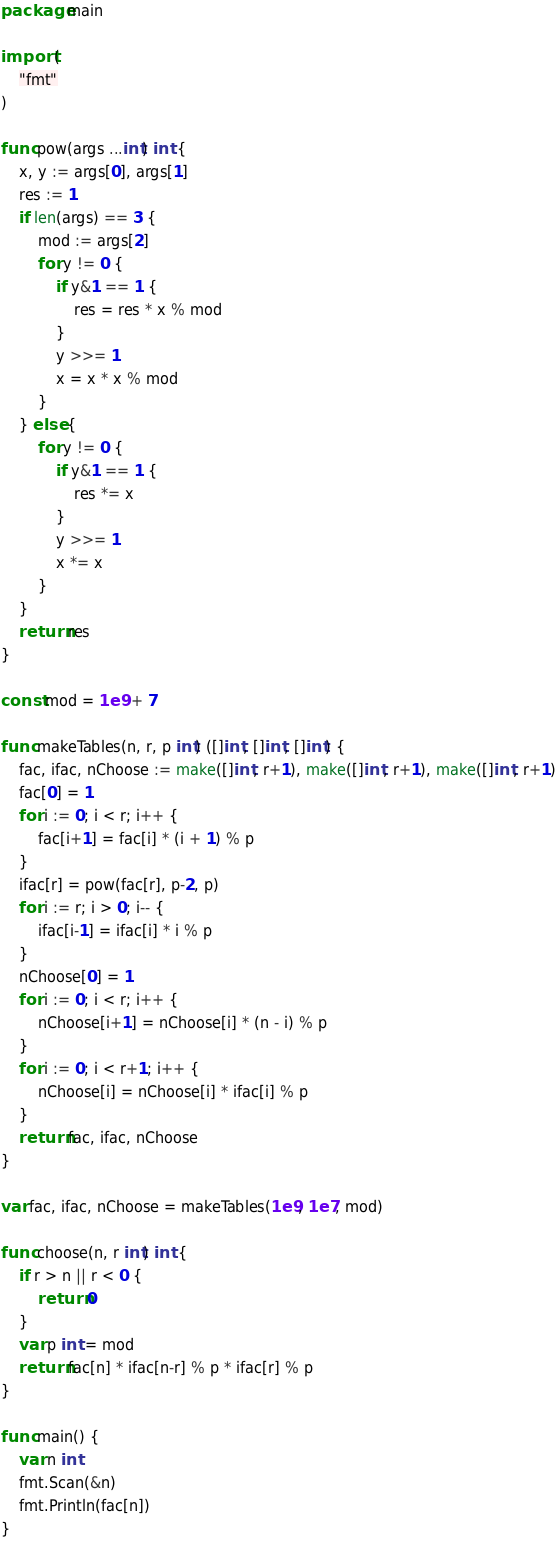<code> <loc_0><loc_0><loc_500><loc_500><_Go_>package main

import (
	"fmt"
)

func pow(args ...int) int {
	x, y := args[0], args[1]
	res := 1
	if len(args) == 3 {
		mod := args[2]
		for y != 0 {
			if y&1 == 1 {
				res = res * x % mod
			}
			y >>= 1
			x = x * x % mod
		}
	} else {
		for y != 0 {
			if y&1 == 1 {
				res *= x
			}
			y >>= 1
			x *= x
		}
	}
	return res
}

const mod = 1e9 + 7

func makeTables(n, r, p int) ([]int, []int, []int) {
	fac, ifac, nChoose := make([]int, r+1), make([]int, r+1), make([]int, r+1)
	fac[0] = 1
	for i := 0; i < r; i++ {
		fac[i+1] = fac[i] * (i + 1) % p
	}
	ifac[r] = pow(fac[r], p-2, p)
	for i := r; i > 0; i-- {
		ifac[i-1] = ifac[i] * i % p
	}
	nChoose[0] = 1
	for i := 0; i < r; i++ {
		nChoose[i+1] = nChoose[i] * (n - i) % p
	}
	for i := 0; i < r+1; i++ {
		nChoose[i] = nChoose[i] * ifac[i] % p
	}
	return fac, ifac, nChoose
}

var fac, ifac, nChoose = makeTables(1e9, 1e7, mod)

func choose(n, r int) int {
	if r > n || r < 0 {
		return 0
	}
	var p int = mod
	return fac[n] * ifac[n-r] % p * ifac[r] % p
}

func main() {
	var n int
	fmt.Scan(&n)
	fmt.Println(fac[n])
}
</code> 